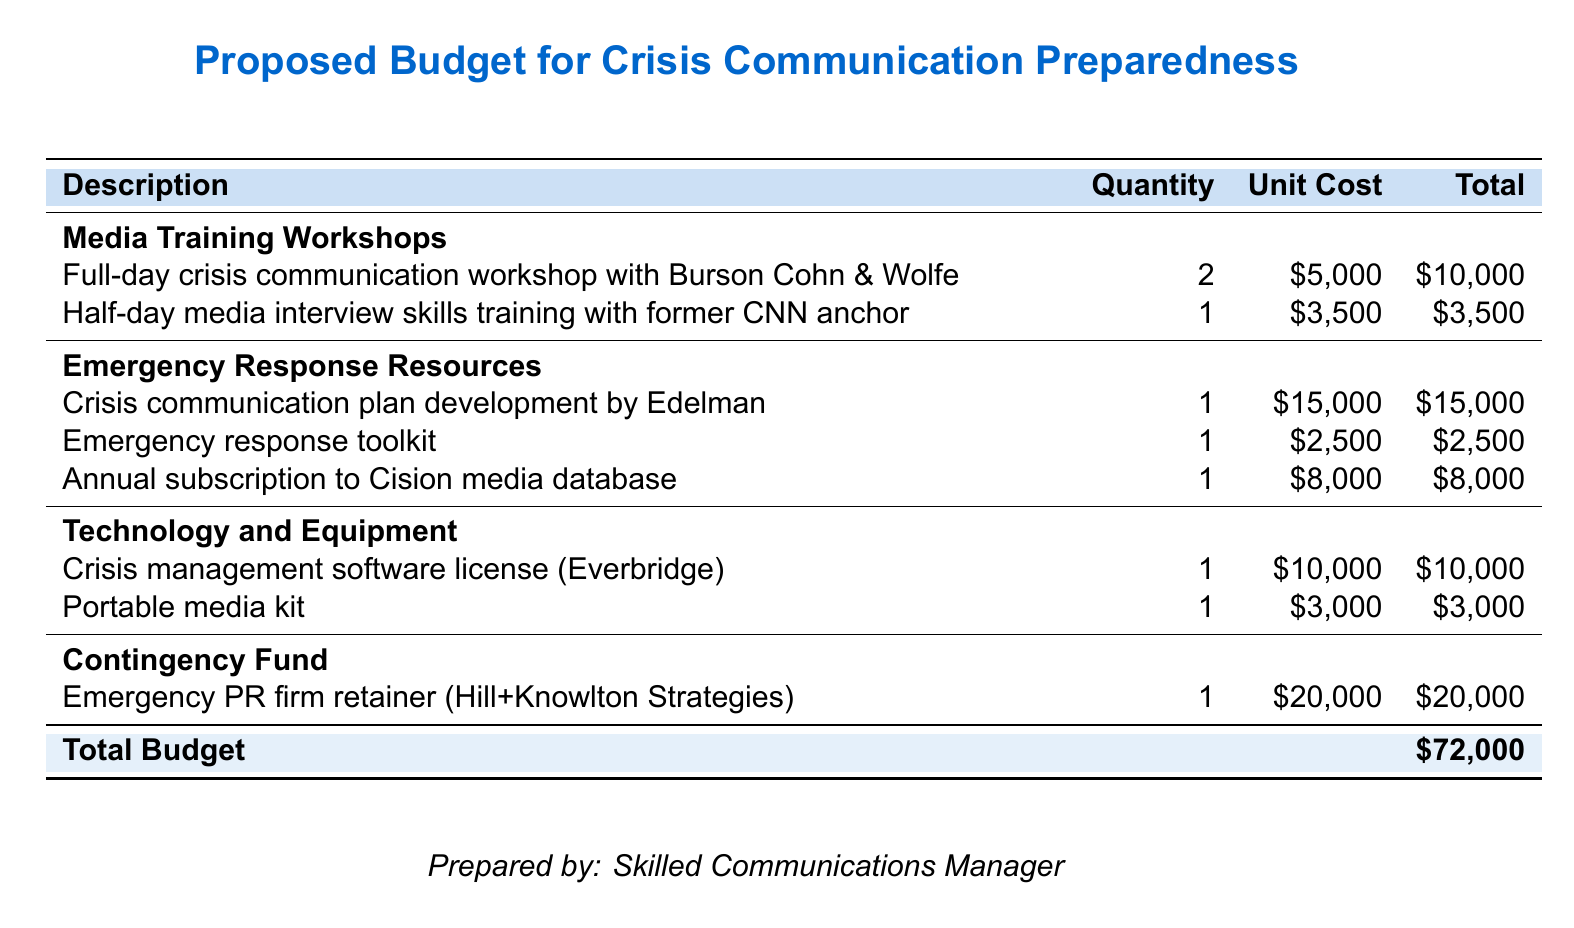What is the total budget? The total budget is presented at the bottom of the table, summing all costs listed.
Answer: $72,000 How many media training workshops are planned? The document lists two types of media training workshops: a full-day and a half-day workshop.
Answer: 2 What is the cost of the crisis communication plan development? The cost for this service is specified in the emergency response resources section of the document.
Answer: $15,000 Who is leading the full-day crisis communication workshop? The document specifies that the workshop is led by Burson Cohn & Wolfe.
Answer: Burson Cohn & Wolfe What is included in the emergency response resources? The section includes a crisis communication plan, toolkit, and media database subscription, among other items.
Answer: Crisis communication plan, emergency response toolkit, annual subscription to Cision media database What is the unit cost of the portable media kit? The document lists the unit cost in the technology and equipment section.
Answer: $3,000 What firm is mentioned for the emergency PR firm retainer? The name of the PR firm is explicitly stated in the contingency fund section.
Answer: Hill+Knowlton Strategies What is the total cost of the media interview skills training? The total cost is found next to the half-day training description in the budget table.
Answer: $3,500 